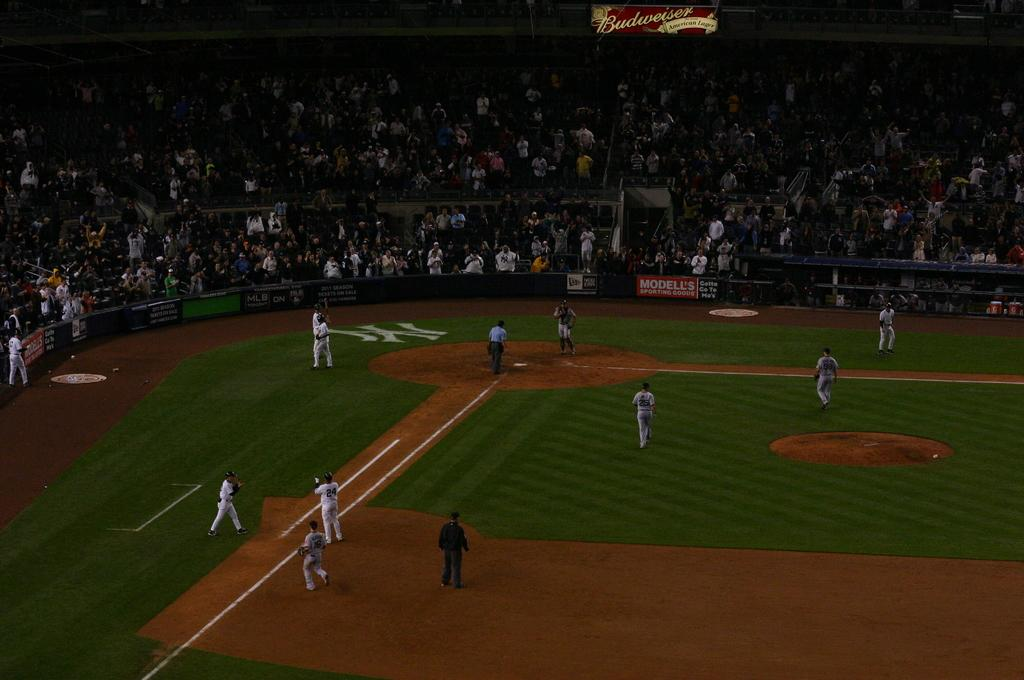<image>
Provide a brief description of the given image. A baseball game being played on the NY Yankees field 